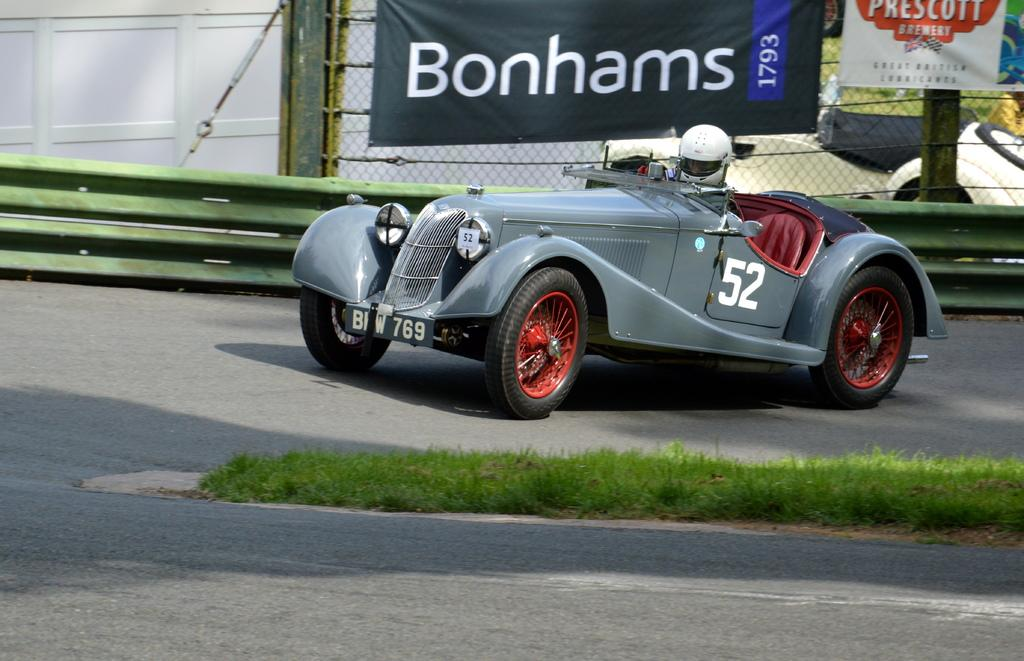What is the person in the image doing? The person is riding a car in the image. What color is the car? The car is grey in color. Where is the car located? The car is on the road. What can be seen behind the car? There is a boundary, fencing, and banners behind the car. What is the ground like at the bottom of the image? The bottom of the image contains grassy land. Can you tell me how many cherries are on the car in the image? There are no cherries present on the car in the image. Is the scene taking place during the night in the image? The image does not provide information about the time of day, but there is no indication of it being night. 